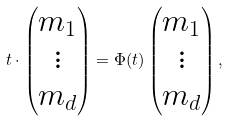<formula> <loc_0><loc_0><loc_500><loc_500>t \cdot \begin{pmatrix} m _ { 1 } \\ \vdots \\ m _ { d } \end{pmatrix} = \Phi ( t ) \begin{pmatrix} m _ { 1 } \\ \vdots \\ m _ { d } \end{pmatrix} ,</formula> 